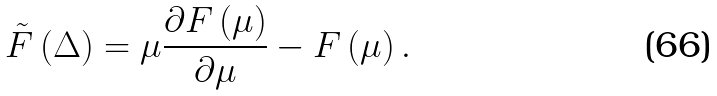<formula> <loc_0><loc_0><loc_500><loc_500>\tilde { F } \left ( \Delta \right ) = \mu \frac { \partial F \left ( \mu \right ) } { \partial \mu } - F \left ( \mu \right ) .</formula> 